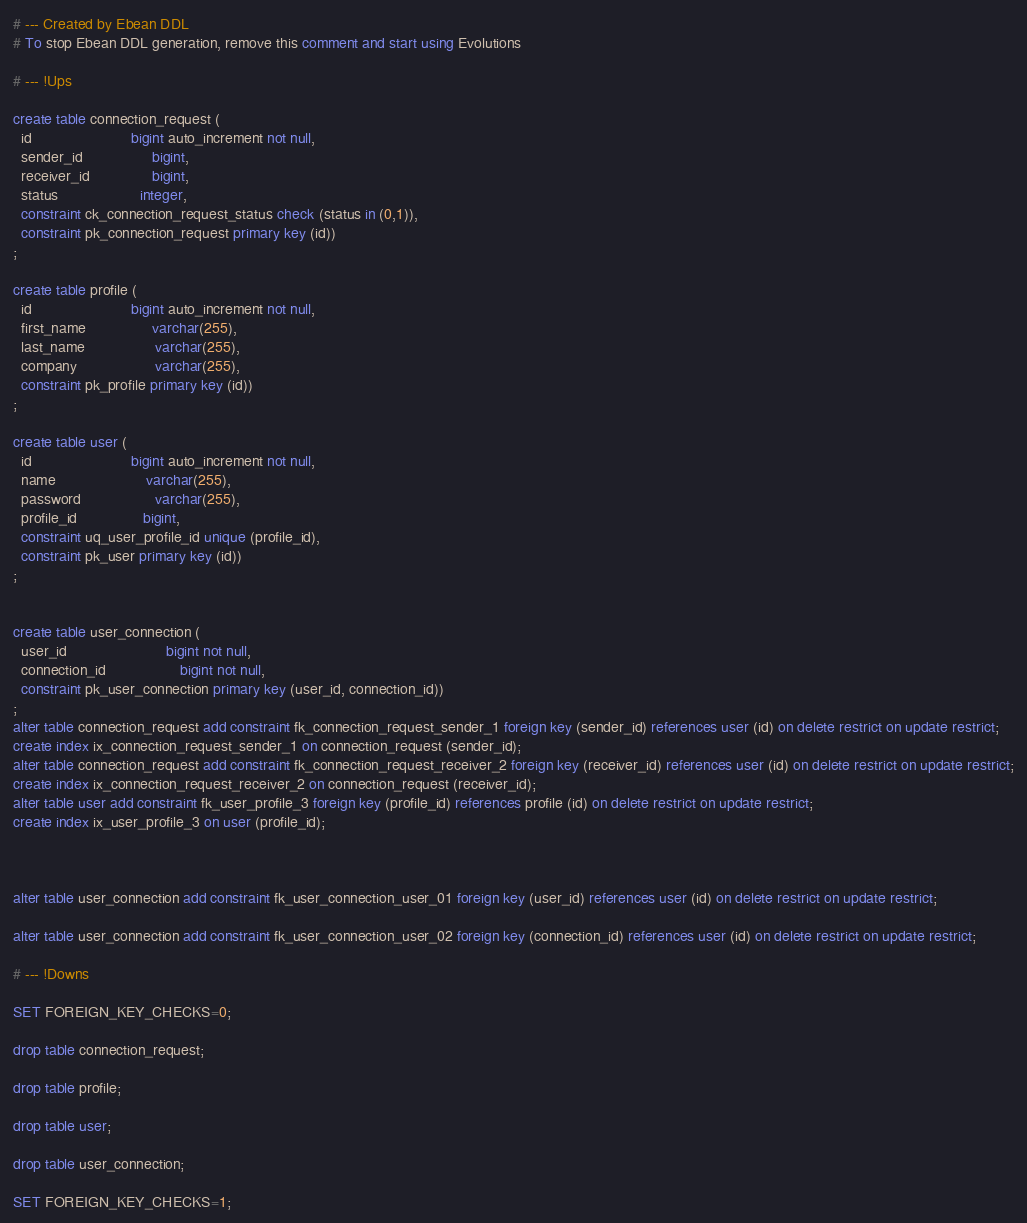Convert code to text. <code><loc_0><loc_0><loc_500><loc_500><_SQL_># --- Created by Ebean DDL
# To stop Ebean DDL generation, remove this comment and start using Evolutions

# --- !Ups

create table connection_request (
  id                        bigint auto_increment not null,
  sender_id                 bigint,
  receiver_id               bigint,
  status                    integer,
  constraint ck_connection_request_status check (status in (0,1)),
  constraint pk_connection_request primary key (id))
;

create table profile (
  id                        bigint auto_increment not null,
  first_name                varchar(255),
  last_name                 varchar(255),
  company                   varchar(255),
  constraint pk_profile primary key (id))
;

create table user (
  id                        bigint auto_increment not null,
  name                      varchar(255),
  password                  varchar(255),
  profile_id                bigint,
  constraint uq_user_profile_id unique (profile_id),
  constraint pk_user primary key (id))
;


create table user_connection (
  user_id                        bigint not null,
  connection_id                  bigint not null,
  constraint pk_user_connection primary key (user_id, connection_id))
;
alter table connection_request add constraint fk_connection_request_sender_1 foreign key (sender_id) references user (id) on delete restrict on update restrict;
create index ix_connection_request_sender_1 on connection_request (sender_id);
alter table connection_request add constraint fk_connection_request_receiver_2 foreign key (receiver_id) references user (id) on delete restrict on update restrict;
create index ix_connection_request_receiver_2 on connection_request (receiver_id);
alter table user add constraint fk_user_profile_3 foreign key (profile_id) references profile (id) on delete restrict on update restrict;
create index ix_user_profile_3 on user (profile_id);



alter table user_connection add constraint fk_user_connection_user_01 foreign key (user_id) references user (id) on delete restrict on update restrict;

alter table user_connection add constraint fk_user_connection_user_02 foreign key (connection_id) references user (id) on delete restrict on update restrict;

# --- !Downs

SET FOREIGN_KEY_CHECKS=0;

drop table connection_request;

drop table profile;

drop table user;

drop table user_connection;

SET FOREIGN_KEY_CHECKS=1;

</code> 